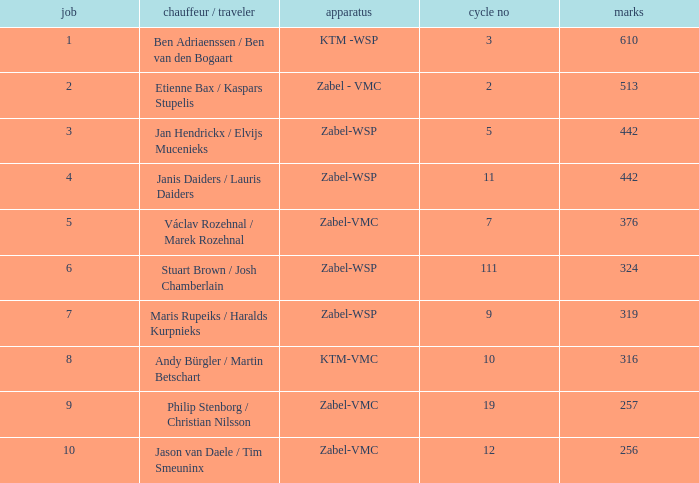What is the Equipment that has a Points littler than 442, and a Position of 9? Zabel-VMC. 